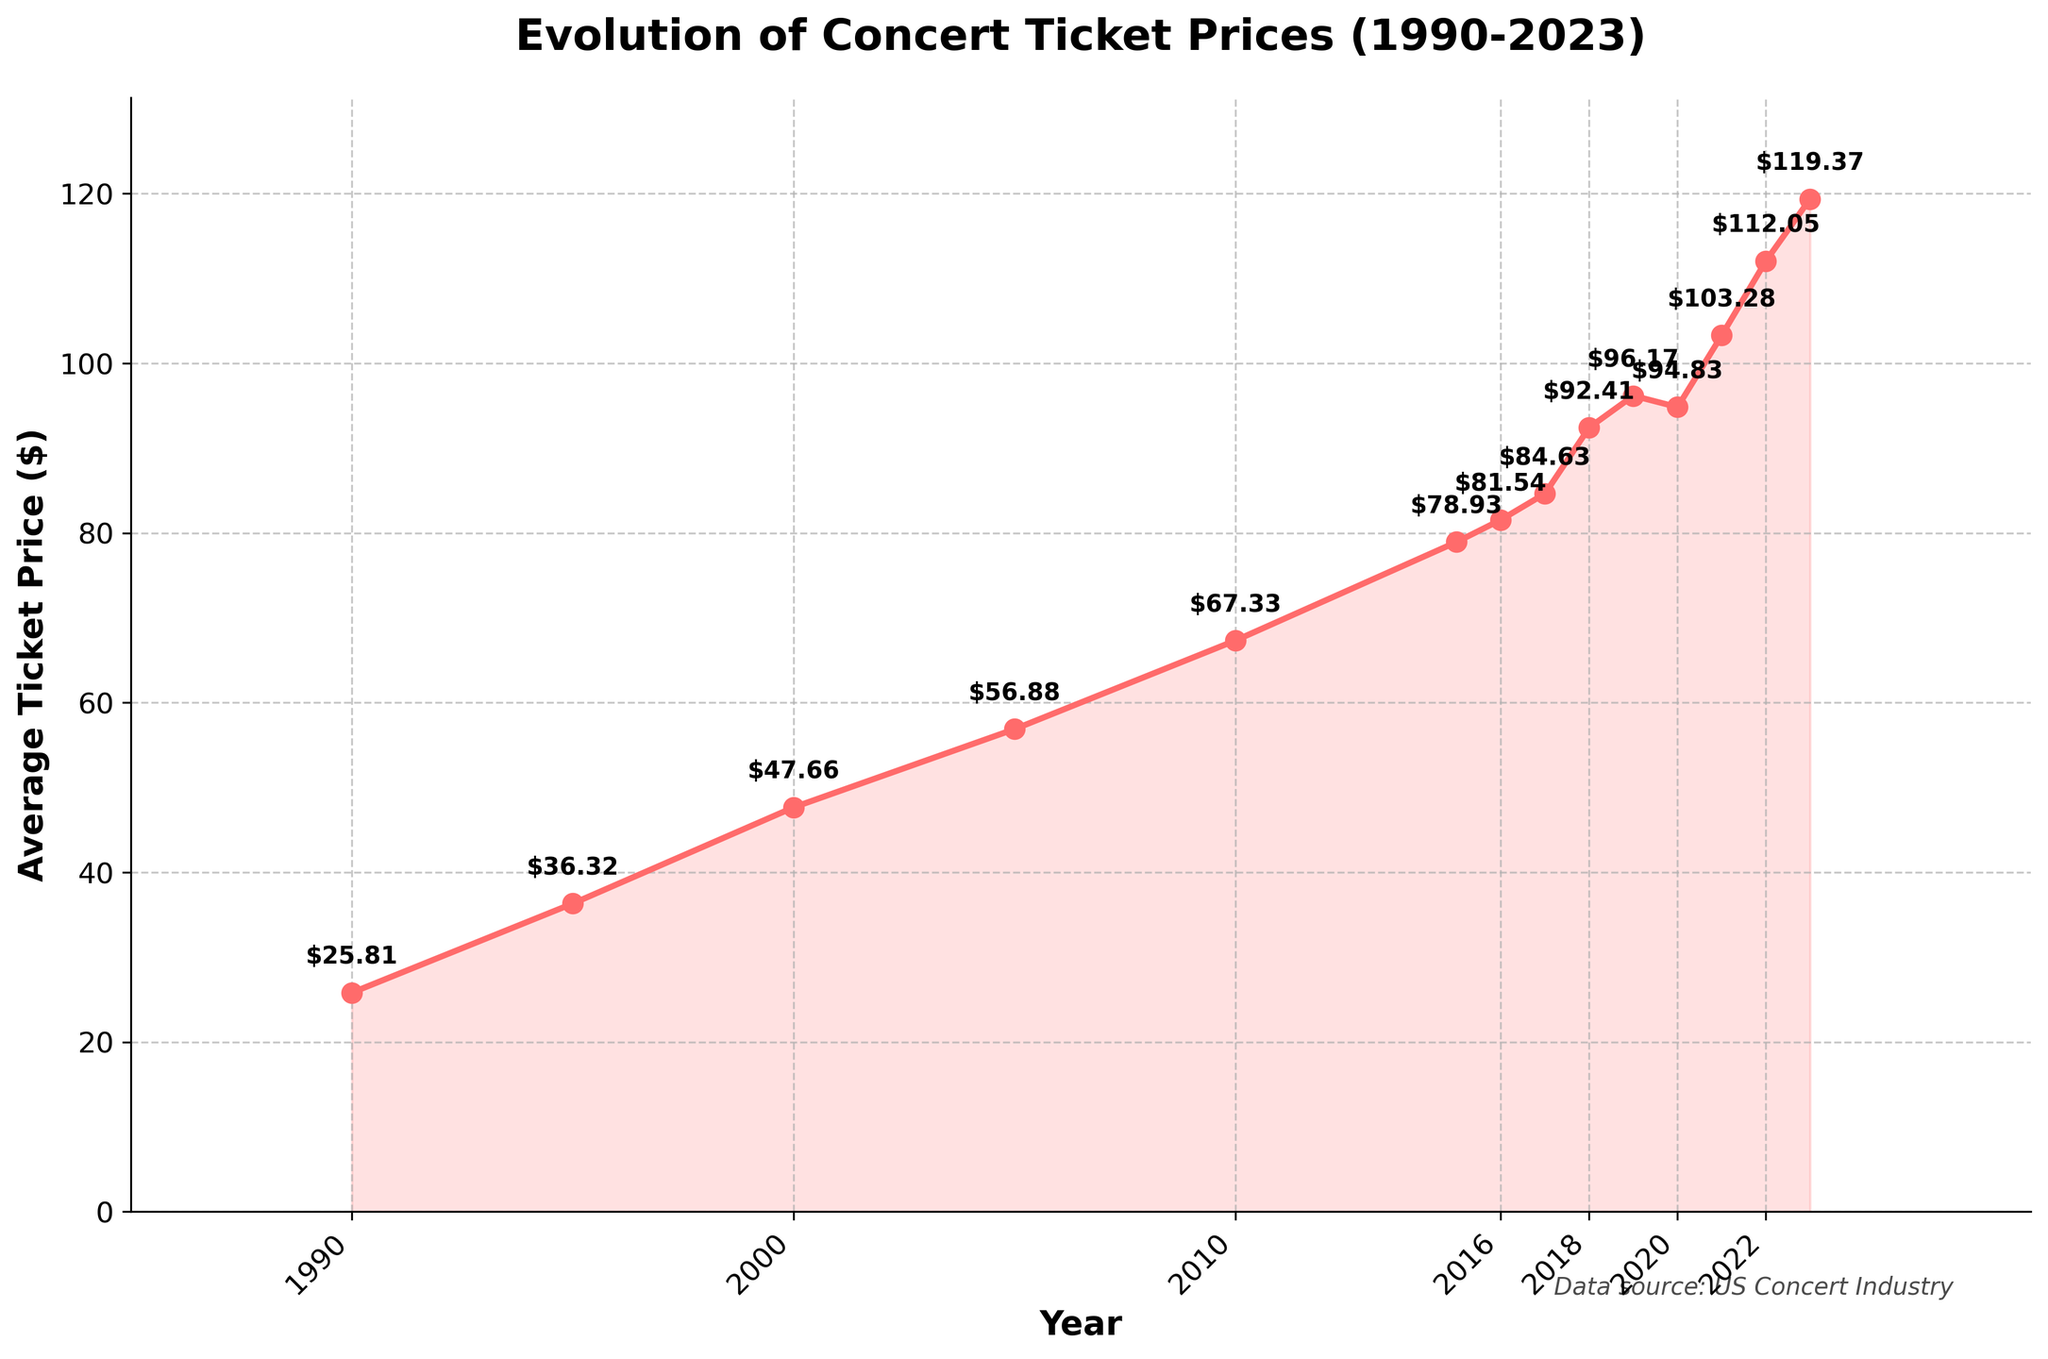What was the average ticket price in 1990? The figure shows the average ticket price for various years, including 1990, marked on the graph. Referencing the year 1990 and the corresponding price annotated next to the data point, we find the value.
Answer: $25.81 How much did the average ticket price increase between 2000 and 2023? To calculate the increase, find the average ticket prices for 2000 and 2023 from the figure, then subtract the price in 2000 from the price in 2023.
Answer: $71.71 Which year saw the highest average ticket price? The highest point on the graph shows the peak average ticket price, marked with an annotation. By checking the highest value, we identify the year corresponding to that value.
Answer: 2023 What is the average ticket price in 2010, and how does it compare to the price in 2015? First, find the average tickets prices for the years 2010 and 2015 from the figure, then compare the two prices to see their difference.
Answer: 2010: $67.33, 2015: $78.93 How many years saw an average ticket price above $90? Identify the annotations for the years where ticket prices exceed $90, and count these specific years.
Answer: 5 years (2018, 2019, 2020, 2021, 2022, 2023) What's the overall trend in average ticket prices from 1990 to 2023? Observing the line graph from left to right, note whether the general direction of the line ascends, descends, or fluctuates without a clear pattern. The consistent upward slope indicates the trend.
Answer: Increasing What is the difference in the average ticket price between 2015 and 2017? Locate the average ticket prices for the years 2015 and 2017 from the annotations on the graph, then subtract the price in 2015 from the price in 2017 to find the difference.
Answer: $5.70 During which years did the average ticket price experience a decrease? Find the years where the line graph shows a downward slope between one year and the next, indicating a decrease in the ticket price.
Answer: 2019 to 2020 When was the first year the average ticket price reached above $50? Locate the first instance on the graph where the ticket price annotation jumps above $50.
Answer: 2005 By how much did the average ticket price increase from 2020 to 2022? Subtract the average ticket price in 2020 from the price in 2022 to find the difference.
Answer: $17.22 